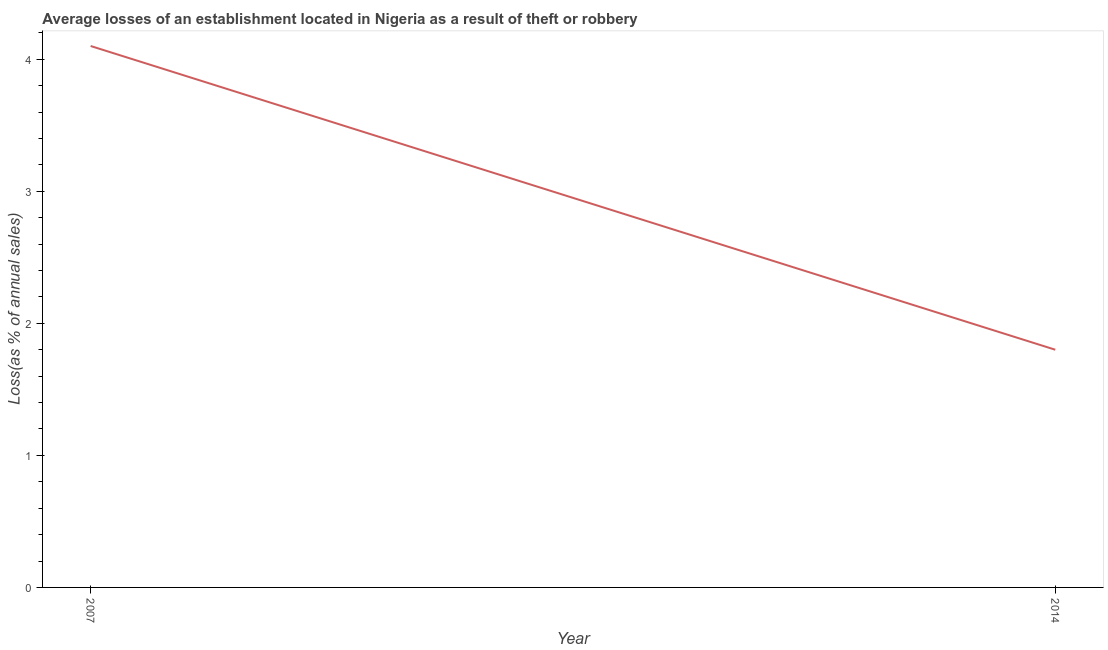Across all years, what is the maximum losses due to theft?
Provide a short and direct response. 4.1. What is the sum of the losses due to theft?
Your answer should be compact. 5.9. What is the difference between the losses due to theft in 2007 and 2014?
Your answer should be compact. 2.3. What is the average losses due to theft per year?
Give a very brief answer. 2.95. What is the median losses due to theft?
Offer a terse response. 2.95. In how many years, is the losses due to theft greater than 2.6 %?
Give a very brief answer. 1. Do a majority of the years between 2007 and 2014 (inclusive) have losses due to theft greater than 0.4 %?
Keep it short and to the point. Yes. What is the ratio of the losses due to theft in 2007 to that in 2014?
Your answer should be very brief. 2.28. Does the losses due to theft monotonically increase over the years?
Give a very brief answer. No. How many lines are there?
Make the answer very short. 1. Are the values on the major ticks of Y-axis written in scientific E-notation?
Offer a terse response. No. Does the graph contain any zero values?
Offer a very short reply. No. Does the graph contain grids?
Make the answer very short. No. What is the title of the graph?
Provide a short and direct response. Average losses of an establishment located in Nigeria as a result of theft or robbery. What is the label or title of the Y-axis?
Keep it short and to the point. Loss(as % of annual sales). What is the ratio of the Loss(as % of annual sales) in 2007 to that in 2014?
Give a very brief answer. 2.28. 